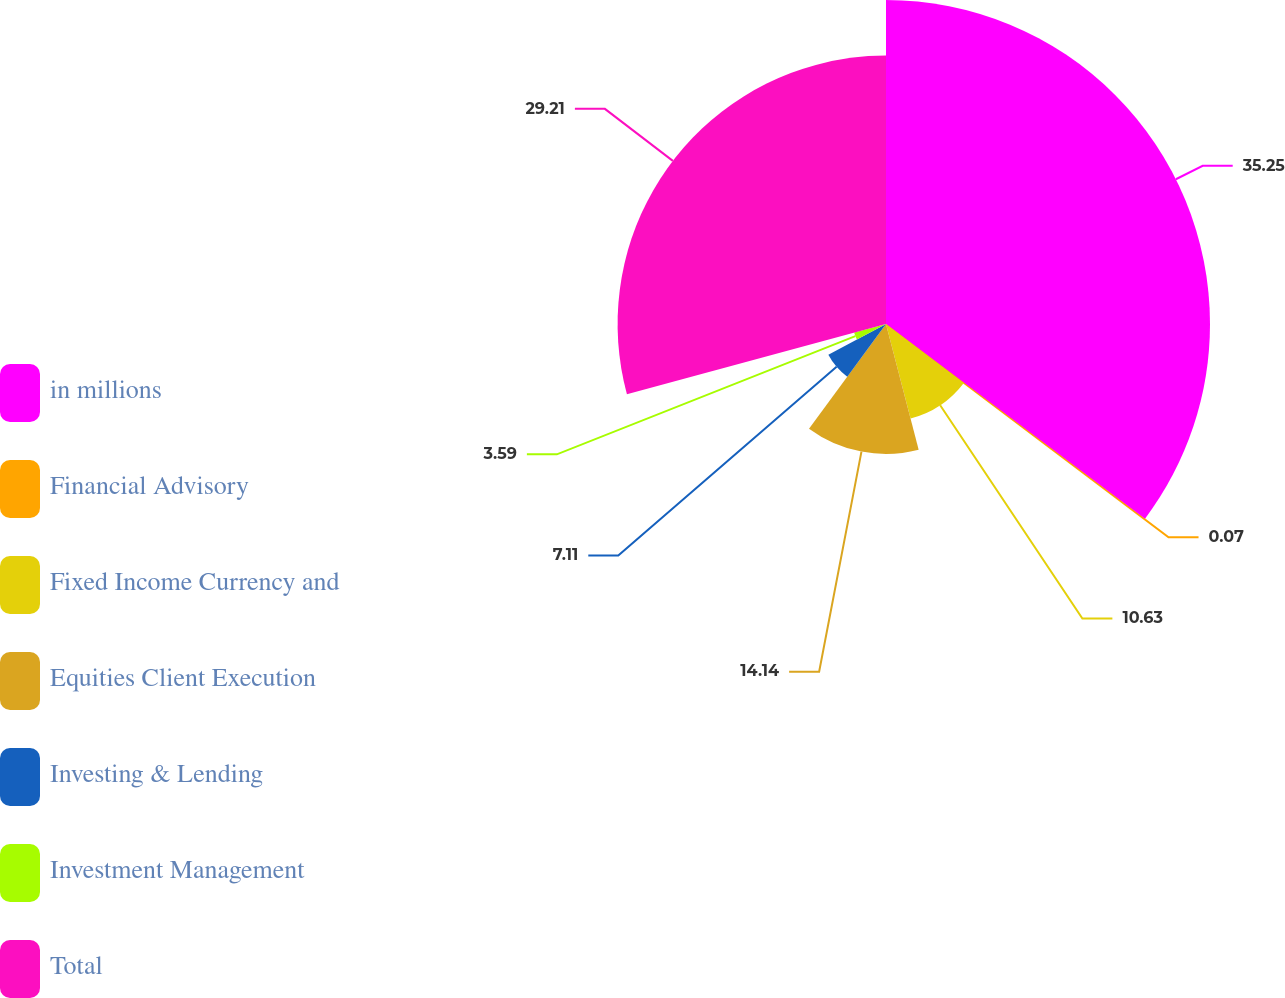<chart> <loc_0><loc_0><loc_500><loc_500><pie_chart><fcel>in millions<fcel>Financial Advisory<fcel>Fixed Income Currency and<fcel>Equities Client Execution<fcel>Investing & Lending<fcel>Investment Management<fcel>Total<nl><fcel>35.26%<fcel>0.07%<fcel>10.63%<fcel>14.14%<fcel>7.11%<fcel>3.59%<fcel>29.21%<nl></chart> 